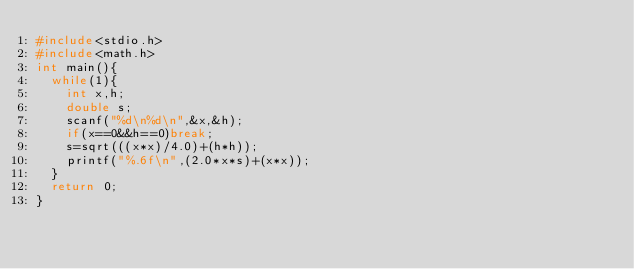Convert code to text. <code><loc_0><loc_0><loc_500><loc_500><_C_>#include<stdio.h>
#include<math.h>
int main(){
  while(1){
    int x,h;
    double s;
    scanf("%d\n%d\n",&x,&h);
    if(x==0&&h==0)break;
    s=sqrt(((x*x)/4.0)+(h*h));
    printf("%.6f\n",(2.0*x*s)+(x*x));
  }
  return 0;
}</code> 